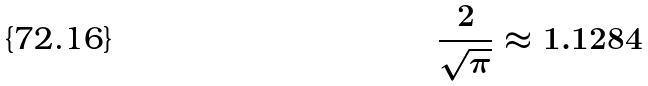Convert formula to latex. <formula><loc_0><loc_0><loc_500><loc_500>\frac { 2 } { \sqrt { \pi } } \approx 1 . 1 2 8 4</formula> 